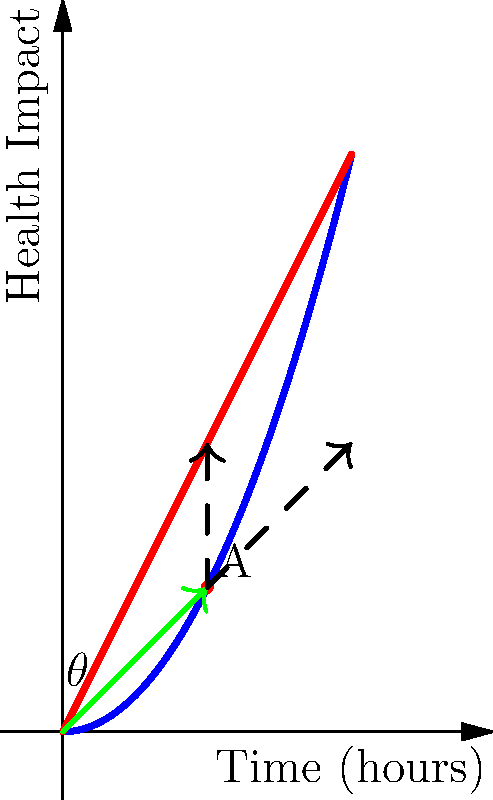In a health optimization study, two exercise routines are represented by vectors $\vec{a}$ (cardio) and $\vec{b}$ (strength training). At point A, where the routines intersect, the angle between them is $\theta$. If $\vec{a} = 2\hat{i} + 2\hat{j}$ and $\vec{b} = 4\hat{i} + 4\hat{j}$, what is the value of $\cos\theta$? To find $\cos\theta$, we'll use the dot product formula:

1) The dot product formula states: $\cos\theta = \frac{\vec{a} \cdot \vec{b}}{|\vec{a}||\vec{b}|}$

2) Calculate $\vec{a} \cdot \vec{b}$:
   $\vec{a} \cdot \vec{b} = (2)(4) + (2)(4) = 8 + 8 = 16$

3) Calculate $|\vec{a}|$:
   $|\vec{a}| = \sqrt{2^2 + 2^2} = \sqrt{8} = 2\sqrt{2}$

4) Calculate $|\vec{b}|$:
   $|\vec{b}| = \sqrt{4^2 + 4^2} = \sqrt{32} = 4\sqrt{2}$

5) Substitute into the formula:
   $\cos\theta = \frac{16}{(2\sqrt{2})(4\sqrt{2})} = \frac{16}{8\sqrt{2}\sqrt{2}} = \frac{16}{16} = 1$

Therefore, $\cos\theta = 1$.
Answer: $1$ 